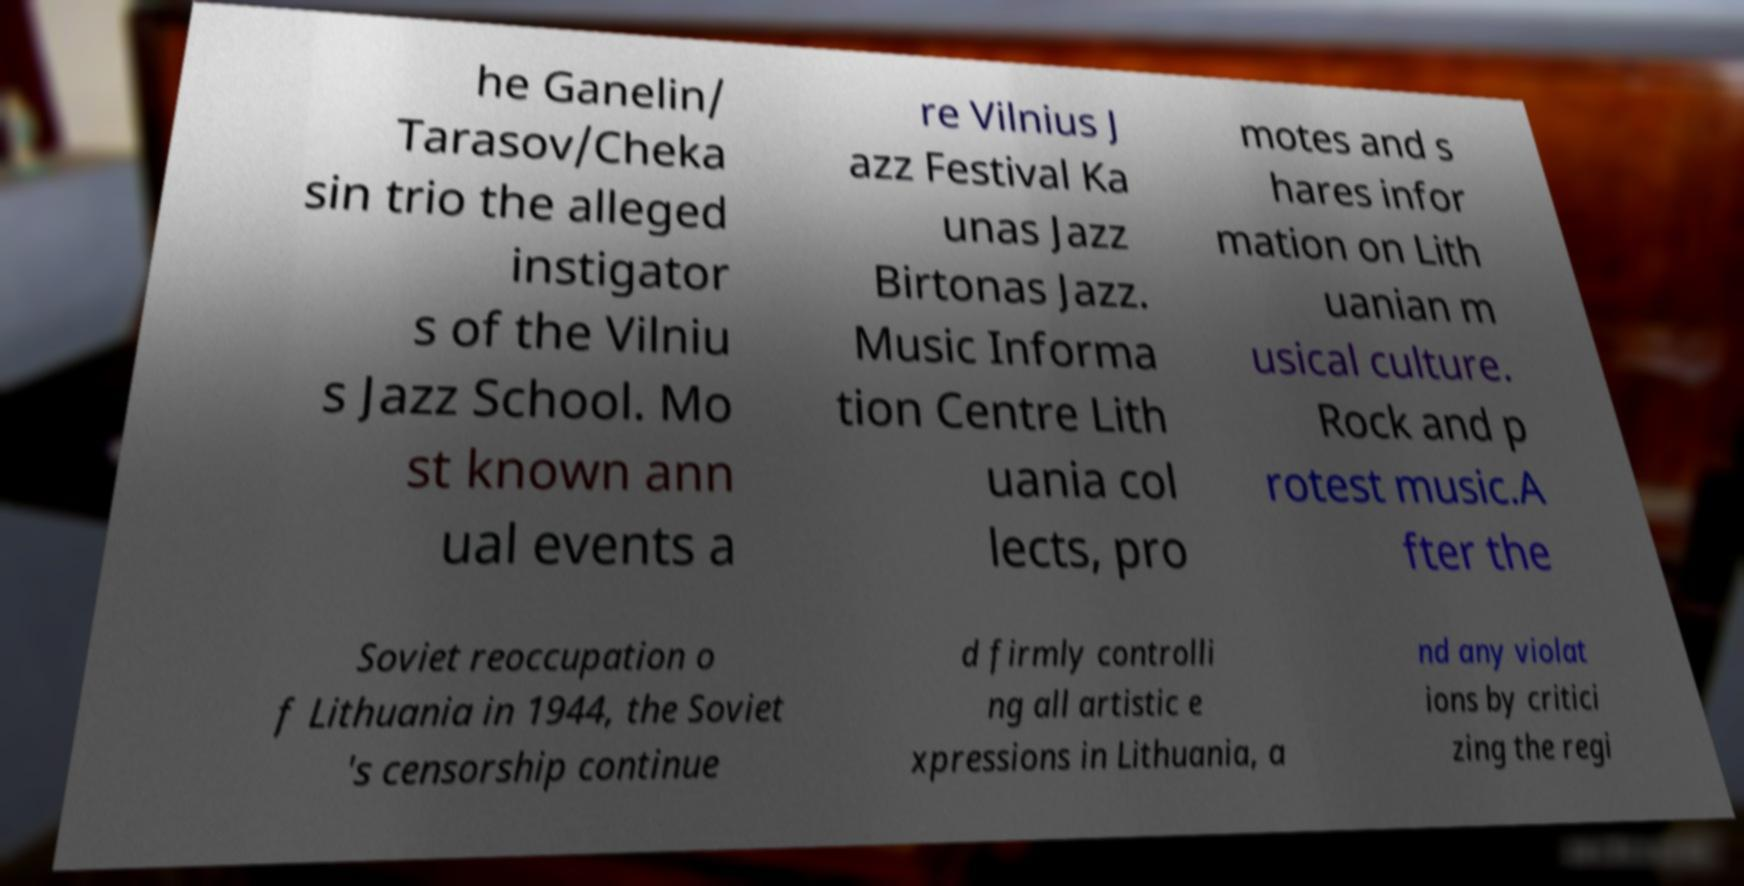Could you assist in decoding the text presented in this image and type it out clearly? he Ganelin/ Tarasov/Cheka sin trio the alleged instigator s of the Vilniu s Jazz School. Mo st known ann ual events a re Vilnius J azz Festival Ka unas Jazz Birtonas Jazz. Music Informa tion Centre Lith uania col lects, pro motes and s hares infor mation on Lith uanian m usical culture. Rock and p rotest music.A fter the Soviet reoccupation o f Lithuania in 1944, the Soviet 's censorship continue d firmly controlli ng all artistic e xpressions in Lithuania, a nd any violat ions by critici zing the regi 